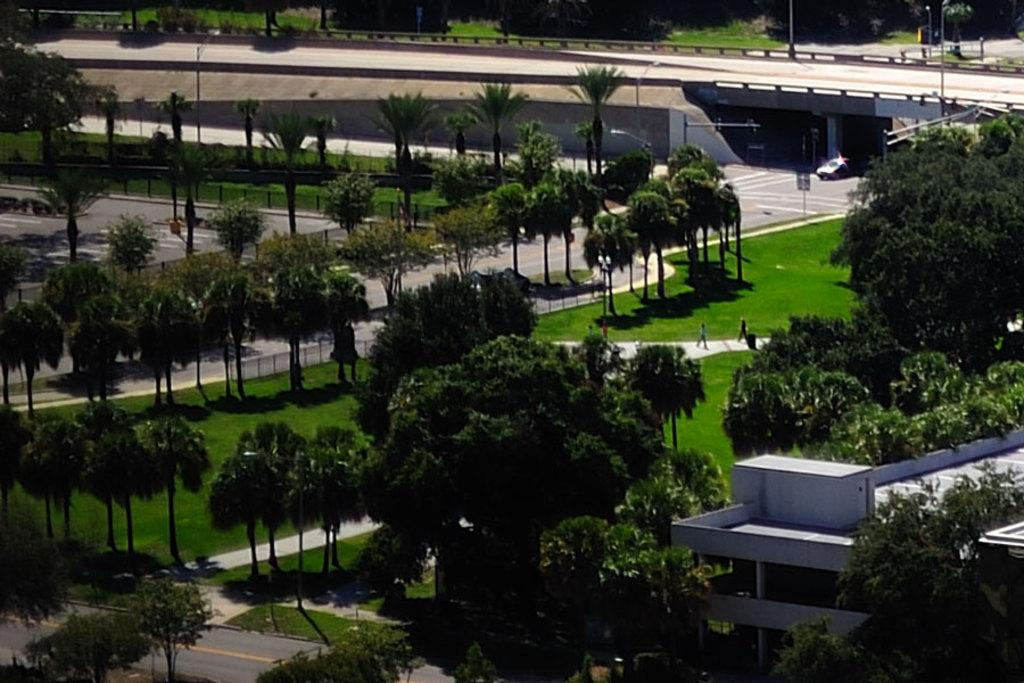What type of vegetation can be seen in the image? There are trees and grass in the image. What structure is located in the bottom right of the image? There is a building in the bottom right of the image. What can be seen in the top right of the image? There is a bridge and a car in the top right of the image. What type of advertisement can be seen on the moon in the image? There is no moon or advertisement present in the image. What is the car carrying in the image? There is no bucket or any indication of what the car might be carrying in the image. 